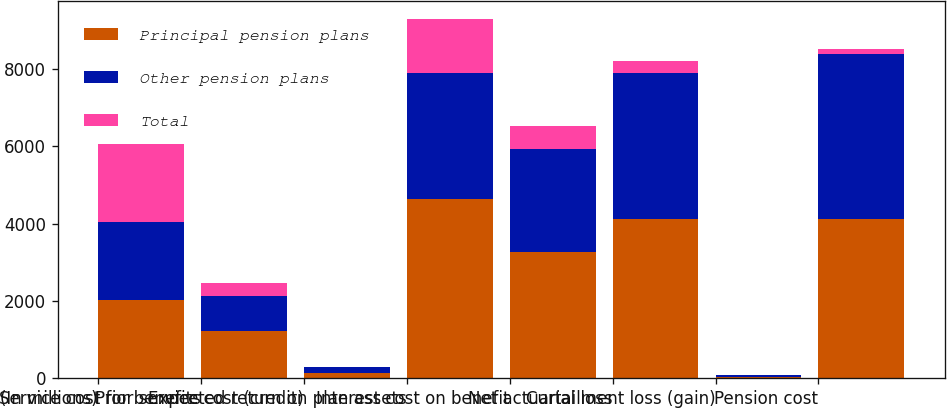Convert chart to OTSL. <chart><loc_0><loc_0><loc_500><loc_500><stacked_bar_chart><ecel><fcel>(In millions)<fcel>Service cost for benefits<fcel>Prior service cost (credit)<fcel>Expected return on plan assets<fcel>Interest cost on benefit<fcel>Net actuarial loss<fcel>Curtailment loss (gain)<fcel>Pension cost<nl><fcel>Principal pension plans<fcel>2018<fcel>1227<fcel>134<fcel>4646<fcel>3270<fcel>4107<fcel>37<fcel>4129<nl><fcel>Other pension plans<fcel>2018<fcel>888<fcel>143<fcel>3248<fcel>2658<fcel>3785<fcel>34<fcel>4260<nl><fcel>Total<fcel>2018<fcel>339<fcel>9<fcel>1398<fcel>612<fcel>322<fcel>3<fcel>131<nl></chart> 